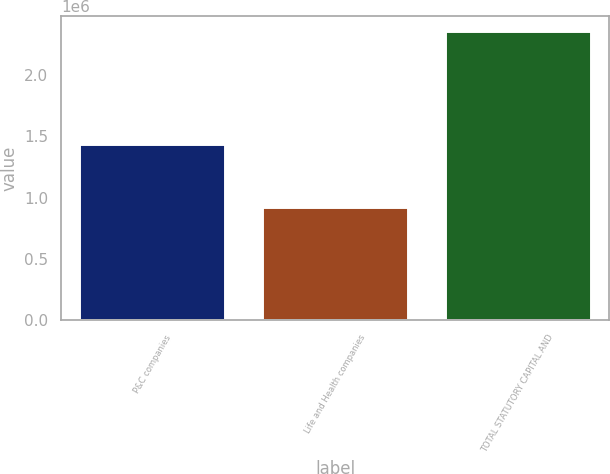<chart> <loc_0><loc_0><loc_500><loc_500><bar_chart><fcel>P&C companies<fcel>Life and Health companies<fcel>TOTAL STATUTORY CAPITAL AND<nl><fcel>1.44039e+06<fcel>923660<fcel>2.36405e+06<nl></chart> 